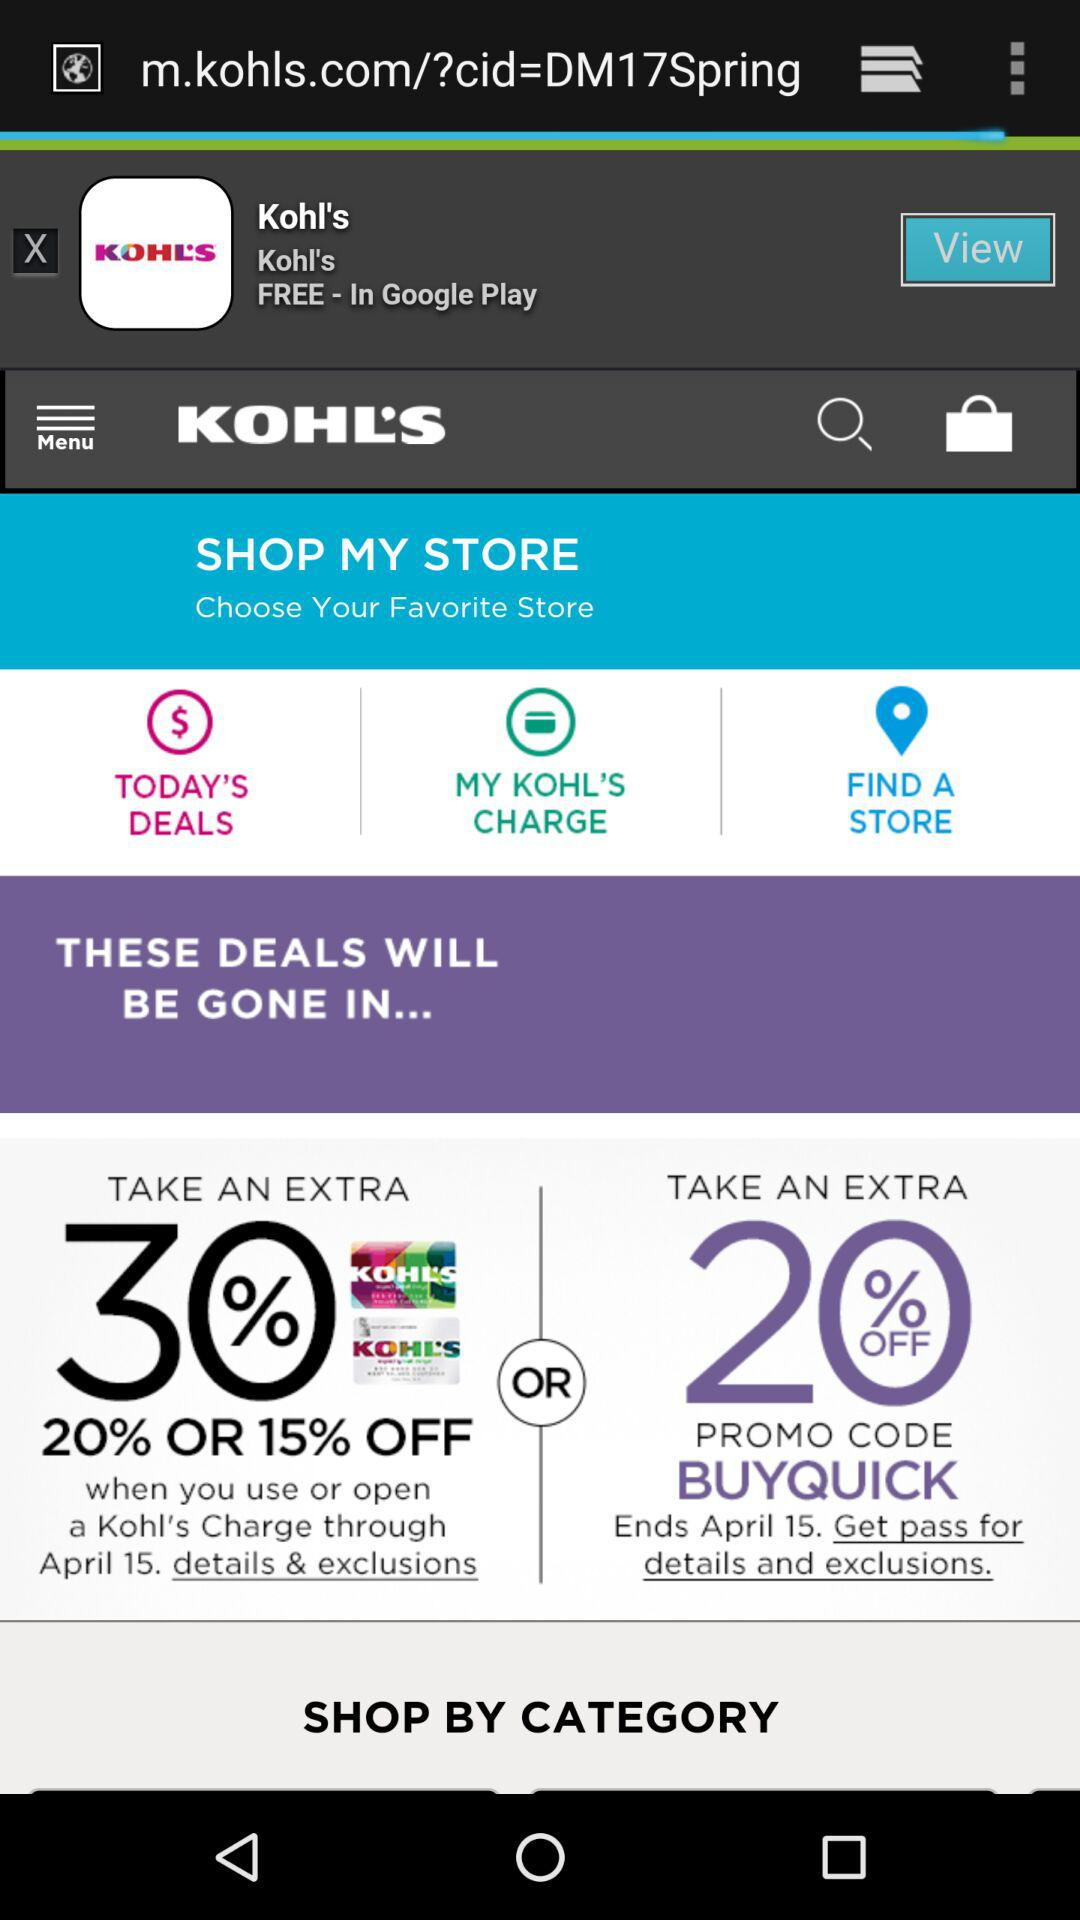What is the promo code? The promo code is "BUYQUICK". 